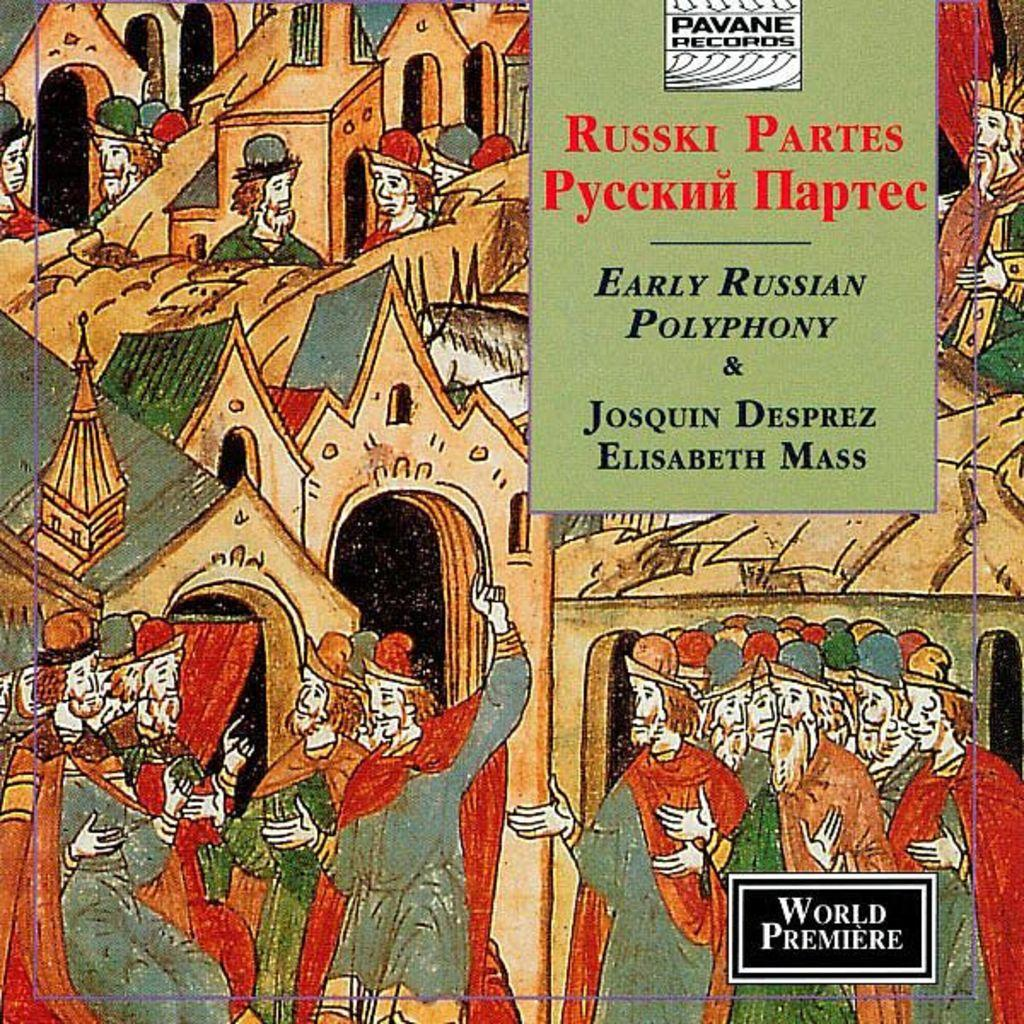Provide a one-sentence caption for the provided image. A advertisement that says Russki Partes Early Russian Polyphony & Josquin Russian Elisabeth Mass. 